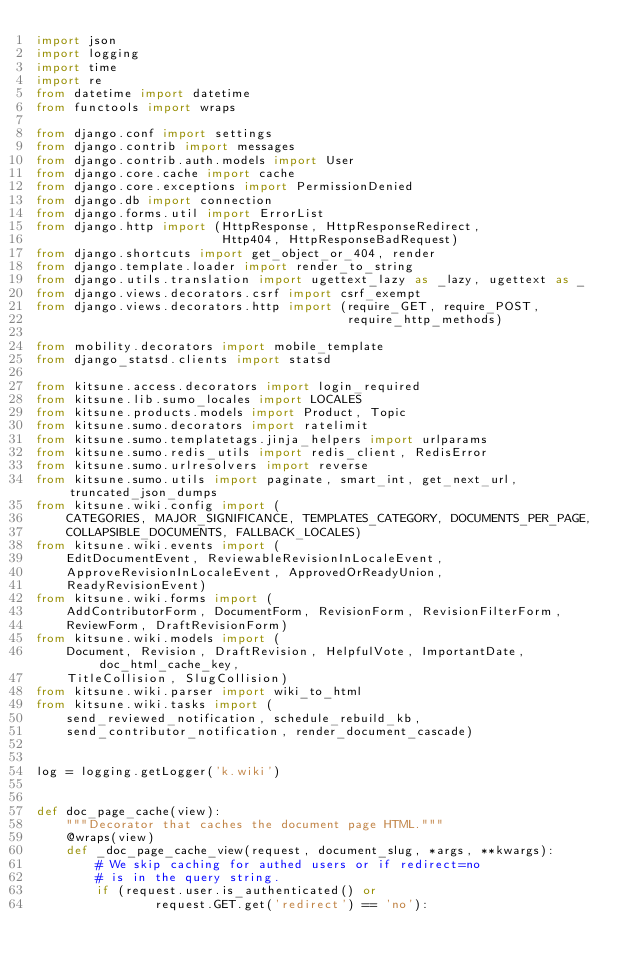<code> <loc_0><loc_0><loc_500><loc_500><_Python_>import json
import logging
import time
import re
from datetime import datetime
from functools import wraps

from django.conf import settings
from django.contrib import messages
from django.contrib.auth.models import User
from django.core.cache import cache
from django.core.exceptions import PermissionDenied
from django.db import connection
from django.forms.util import ErrorList
from django.http import (HttpResponse, HttpResponseRedirect,
                         Http404, HttpResponseBadRequest)
from django.shortcuts import get_object_or_404, render
from django.template.loader import render_to_string
from django.utils.translation import ugettext_lazy as _lazy, ugettext as _
from django.views.decorators.csrf import csrf_exempt
from django.views.decorators.http import (require_GET, require_POST,
                                          require_http_methods)

from mobility.decorators import mobile_template
from django_statsd.clients import statsd

from kitsune.access.decorators import login_required
from kitsune.lib.sumo_locales import LOCALES
from kitsune.products.models import Product, Topic
from kitsune.sumo.decorators import ratelimit
from kitsune.sumo.templatetags.jinja_helpers import urlparams
from kitsune.sumo.redis_utils import redis_client, RedisError
from kitsune.sumo.urlresolvers import reverse
from kitsune.sumo.utils import paginate, smart_int, get_next_url, truncated_json_dumps
from kitsune.wiki.config import (
    CATEGORIES, MAJOR_SIGNIFICANCE, TEMPLATES_CATEGORY, DOCUMENTS_PER_PAGE,
    COLLAPSIBLE_DOCUMENTS, FALLBACK_LOCALES)
from kitsune.wiki.events import (
    EditDocumentEvent, ReviewableRevisionInLocaleEvent,
    ApproveRevisionInLocaleEvent, ApprovedOrReadyUnion,
    ReadyRevisionEvent)
from kitsune.wiki.forms import (
    AddContributorForm, DocumentForm, RevisionForm, RevisionFilterForm,
    ReviewForm, DraftRevisionForm)
from kitsune.wiki.models import (
    Document, Revision, DraftRevision, HelpfulVote, ImportantDate, doc_html_cache_key,
    TitleCollision, SlugCollision)
from kitsune.wiki.parser import wiki_to_html
from kitsune.wiki.tasks import (
    send_reviewed_notification, schedule_rebuild_kb,
    send_contributor_notification, render_document_cascade)


log = logging.getLogger('k.wiki')


def doc_page_cache(view):
    """Decorator that caches the document page HTML."""
    @wraps(view)
    def _doc_page_cache_view(request, document_slug, *args, **kwargs):
        # We skip caching for authed users or if redirect=no
        # is in the query string.
        if (request.user.is_authenticated() or
                request.GET.get('redirect') == 'no'):</code> 